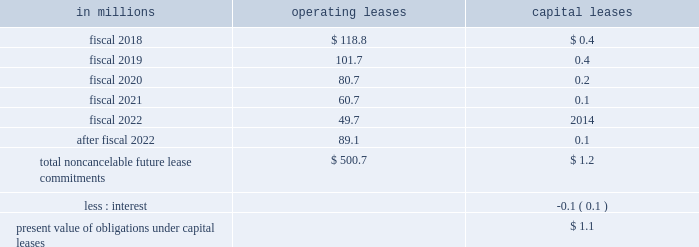Able to reasonably estimate the timing of future cash flows beyond 12 months due to uncertainties in the timing of tax audit outcomes .
The remaining amount of our unrecognized tax liability was classified in other liabilities .
We report accrued interest and penalties related to unrecognized tax benefit liabilities in income tax expense .
For fiscal 2017 , we recognized a net benefit of $ 5.6 million of tax-related net interest and penalties , and had $ 23.1 million of accrued interest and penalties as of may 28 , 2017 .
For fiscal 2016 , we recognized a net benefit of $ 2.7 million of tax-related net interest and penalties , and had $ 32.1 million of accrued interest and penalties as of may 29 , 2016 .
Note 15 .
Leases , other commitments , and contingencies the company 2019s leases are generally for warehouse space and equipment .
Rent expense under all operating leases from continuing operations was $ 188.1 million in fiscal 2017 , $ 189.1 million in fiscal 2016 , and $ 193.5 million in fiscal 2015 .
Some operating leases require payment of property taxes , insurance , and maintenance costs in addition to the rent payments .
Contingent and escalation rent in excess of minimum rent payments and sublease income netted in rent expense were insignificant .
Noncancelable future lease commitments are : operating capital in millions leases leases .
Depreciation on capital leases is recorded as deprecia- tion expense in our results of operations .
As of may 28 , 2017 , we have issued guarantees and comfort letters of $ 504.7 million for the debt and other obligations of consolidated subsidiaries , and guarantees and comfort letters of $ 165.3 million for the debt and other obligations of non-consolidated affiliates , mainly cpw .
In addition , off-balance sheet arrangements are generally limited to the future payments under non-cancelable operating leases , which totaled $ 500.7 million as of may 28 , 2017 .
Note 16 .
Business segment and geographic information we operate in the consumer foods industry .
In the third quarter of fiscal 2017 , we announced a new global orga- nization structure to streamline our leadership , enhance global scale , and drive improved operational agility to maximize our growth capabilities .
As a result of this global reorganization , beginning in the third quarter of fiscal 2017 , we reported results for our four operating segments as follows : north america retail , 65.3 percent of our fiscal 2017 consolidated net sales ; convenience stores & foodservice , 12.0 percent of our fiscal 2017 consolidated net sales ; europe & australia , 11.7 percent of our fiscal 2017 consolidated net sales ; and asia & latin america , 11.0 percent of our fiscal 2017 consoli- dated net sales .
We have restated our net sales by seg- ment and segment operating profit amounts to reflect our new operating segments .
These segment changes had no effect on previously reported consolidated net sales , operating profit , net earnings attributable to general mills , or earnings per share .
Our north america retail operating segment consists of our former u.s .
Retail operating units and our canada region .
Within our north america retail operating seg- ment , our former u.s .
Meals operating unit and u.s .
Baking operating unit have been combined into one operating unit : u.s .
Meals & baking .
Our convenience stores & foodservice operating segment is unchanged .
Our europe & australia operating segment consists of our former europe region .
Our asia & latin america operating segment consists of our former asia/pacific and latin america regions .
Under our new organization structure , our chief operating decision maker assesses performance and makes decisions about resources to be allocated to our segments at the north america retail , convenience stores & foodservice , europe & australia , and asia & latin america operating segment level .
Our north america retail operating segment reflects business with a wide variety of grocery stores , mass merchandisers , membership stores , natural food chains , drug , dollar and discount chains , and e-commerce gro- cery providers .
Our product categories in this business 84 general mills .
In 2016 what was the ratio of the net benefit recognized to the accrued interest and penalties? 
Computations: (2.7 / 32.1)
Answer: 0.08411. 